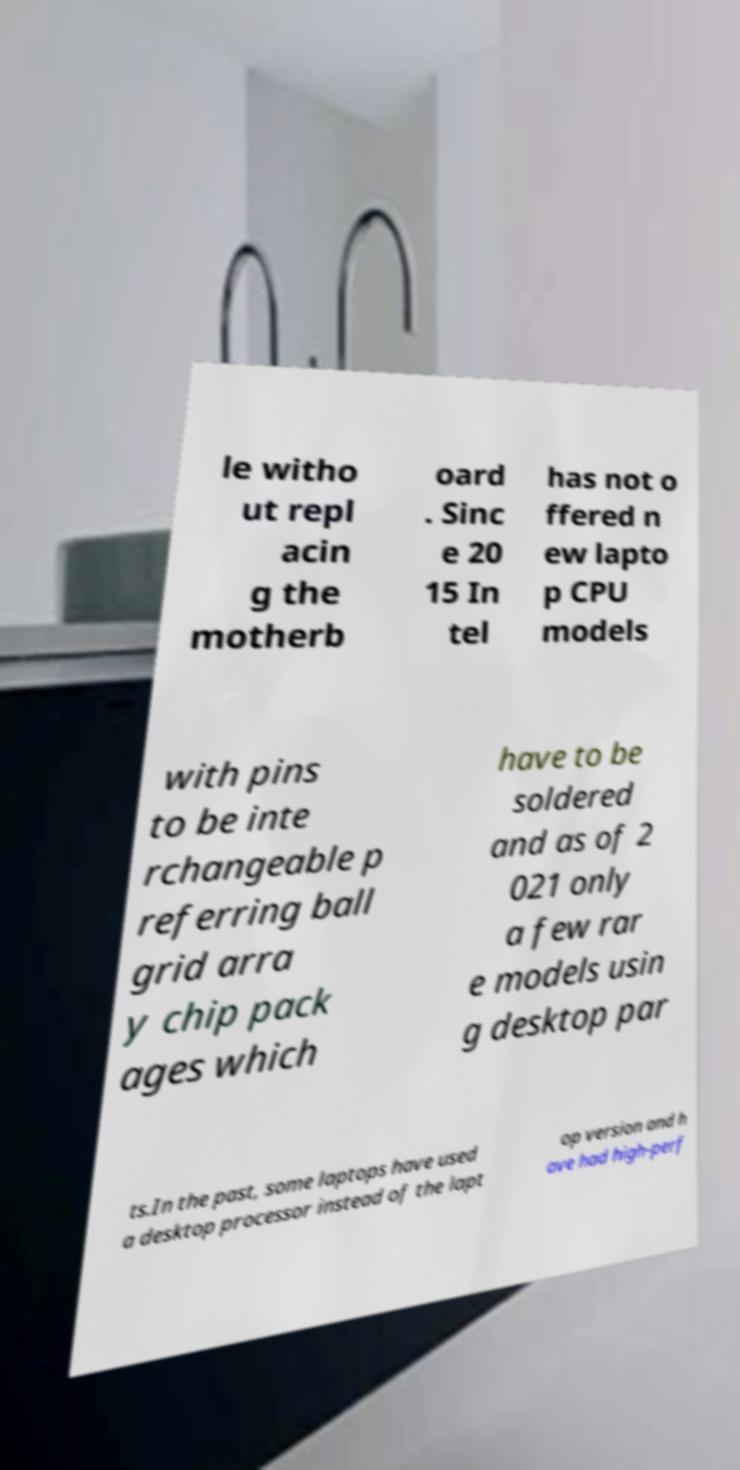Can you read and provide the text displayed in the image?This photo seems to have some interesting text. Can you extract and type it out for me? le witho ut repl acin g the motherb oard . Sinc e 20 15 In tel has not o ffered n ew lapto p CPU models with pins to be inte rchangeable p referring ball grid arra y chip pack ages which have to be soldered and as of 2 021 only a few rar e models usin g desktop par ts.In the past, some laptops have used a desktop processor instead of the lapt op version and h ave had high-perf 